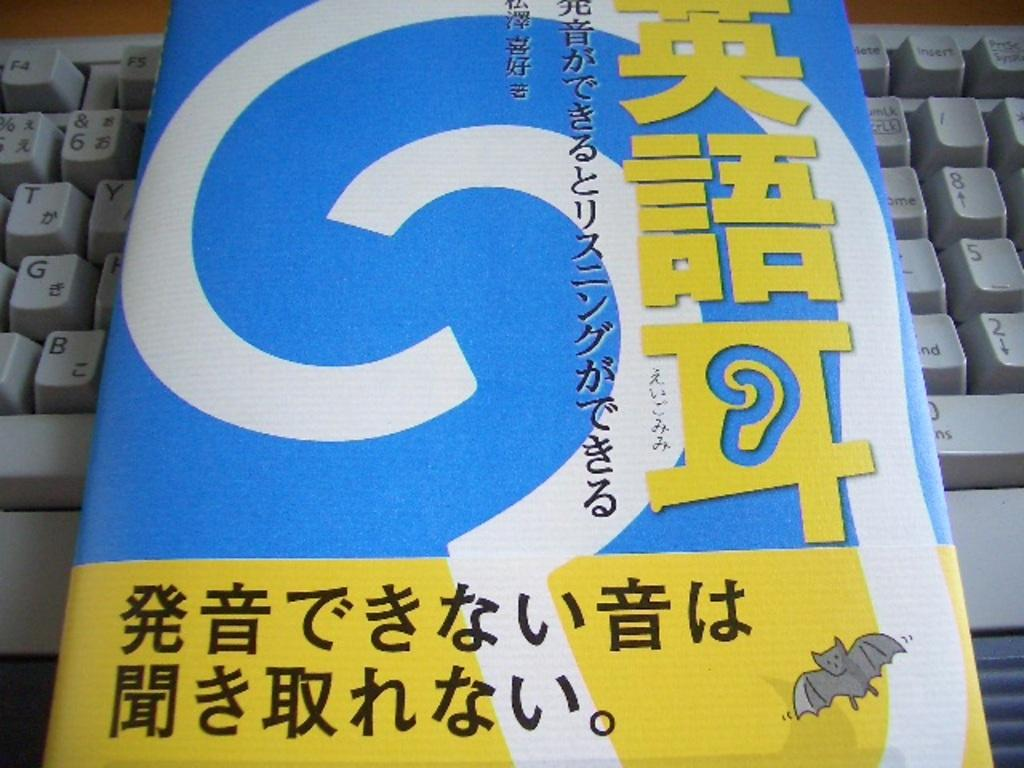<image>
Describe the image concisely. A package with a small cartoon bat on it sits right next to the B and G keys on a computer keyboard. 